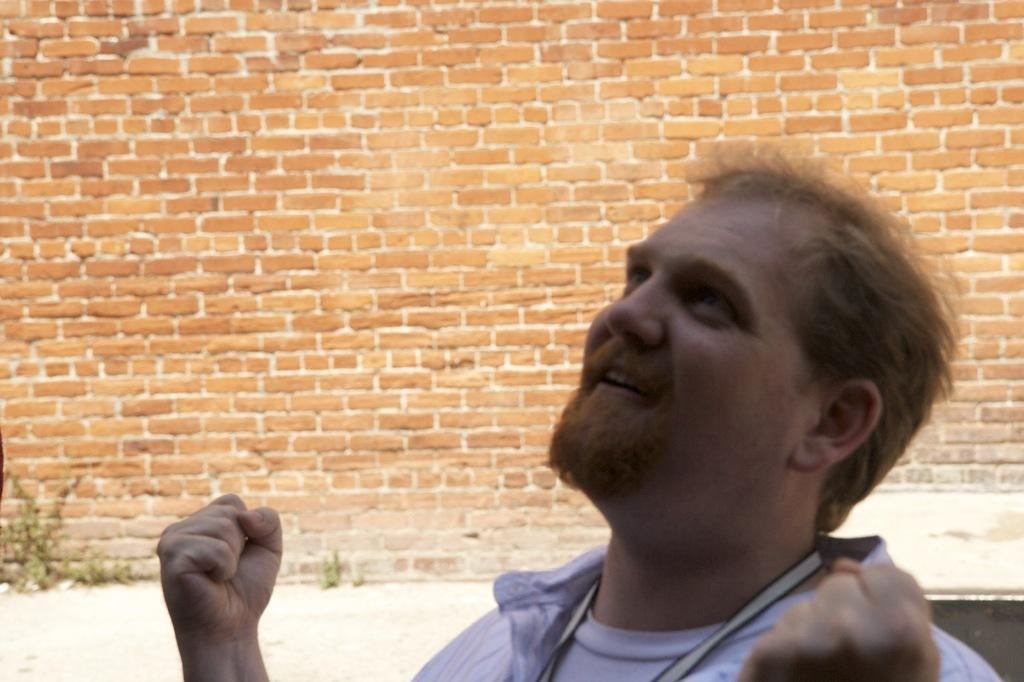Who is present in the image? There is a man in the image. What can be seen in the background of the image? There is a brick wall in the background of the image. What is located in front of the brick wall? There is a plant in front of the brick wall. What type of grape is growing on the plant in the image? There is no grape plant present in the image; it features a man, a brick wall, and a plant, but no grapes. Is there a scarecrow standing near the plant in the image? There is no scarecrow present in the image. 